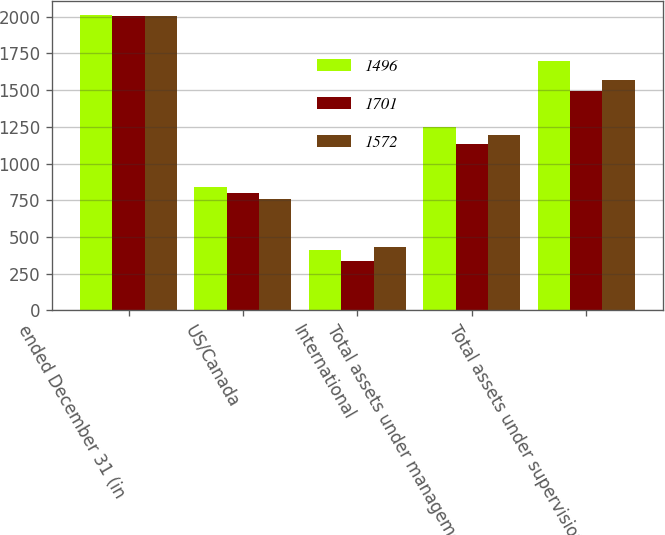Convert chart. <chart><loc_0><loc_0><loc_500><loc_500><stacked_bar_chart><ecel><fcel>ended December 31 (in<fcel>US/Canada<fcel>International<fcel>Total assets under management<fcel>Total assets under supervision<nl><fcel>1496<fcel>2009<fcel>837<fcel>412<fcel>1249<fcel>1701<nl><fcel>1701<fcel>2008<fcel>798<fcel>335<fcel>1133<fcel>1496<nl><fcel>1572<fcel>2007<fcel>760<fcel>433<fcel>1193<fcel>1572<nl></chart> 